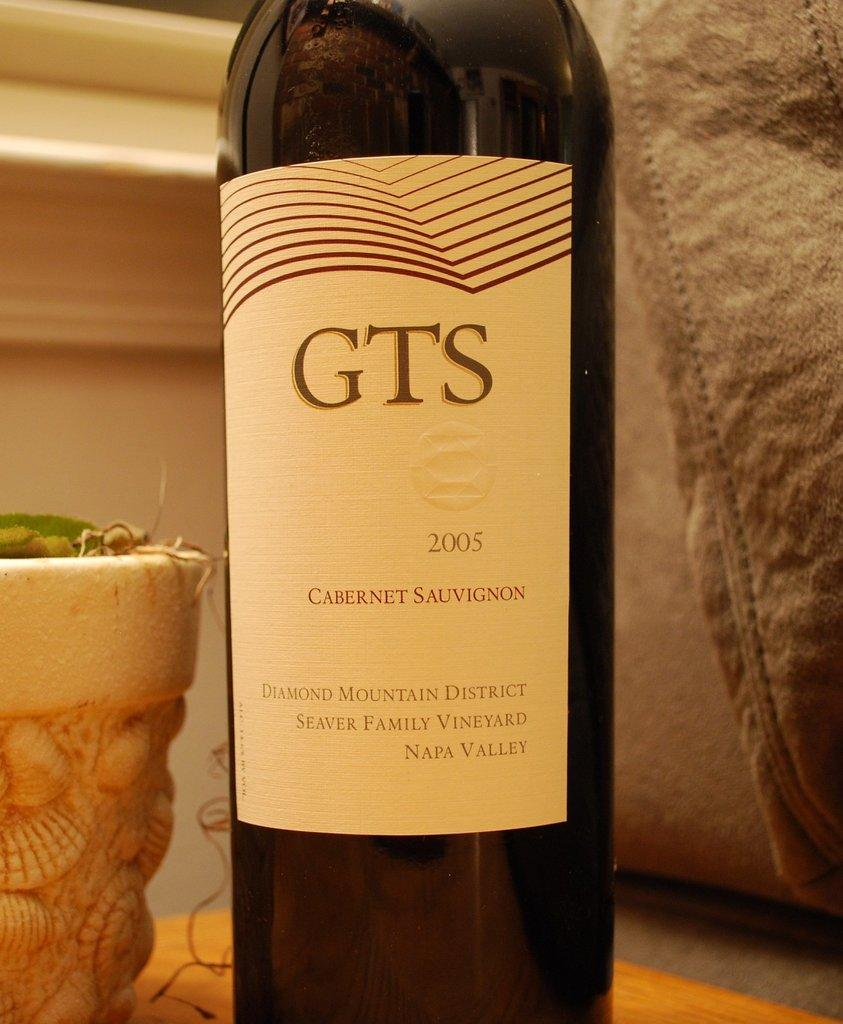<image>
Relay a brief, clear account of the picture shown. A bottle of cabernet sauvignon 2005 with the brand GTS. 